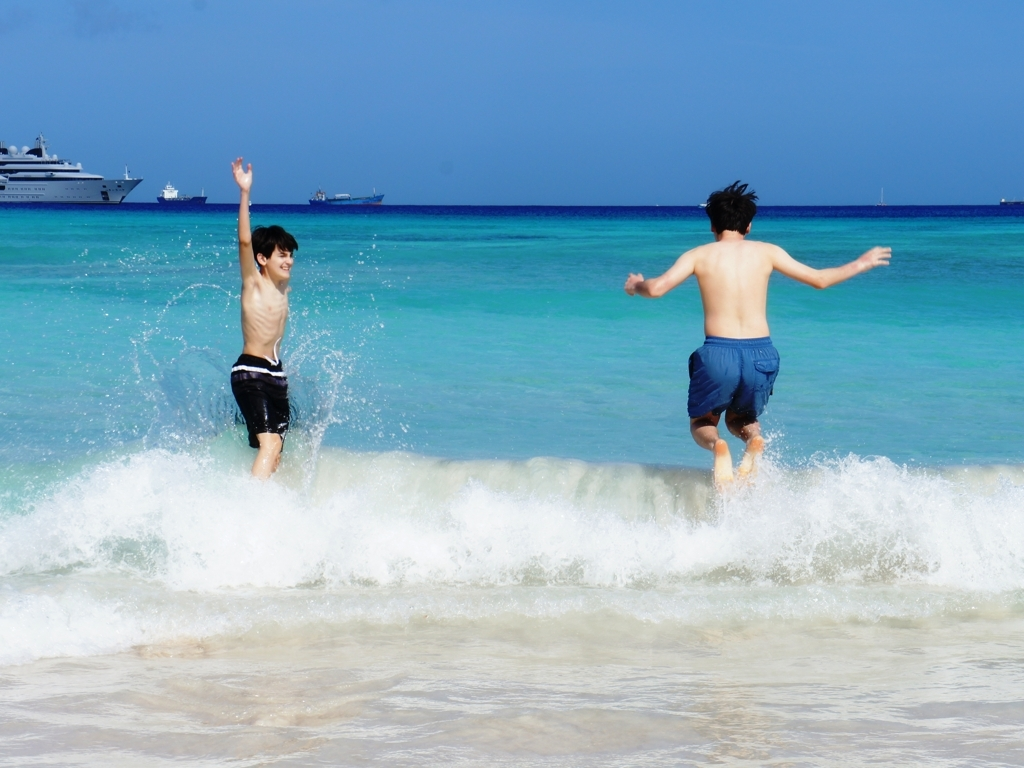Is this image suitable for promoting tourism, and why? Yes, this image is highly suitable for promoting tourism as it showcases a pristine beach environment with inviting waters, clear skies, and a sense of enjoyment that is often sought after in vacation destinations. 